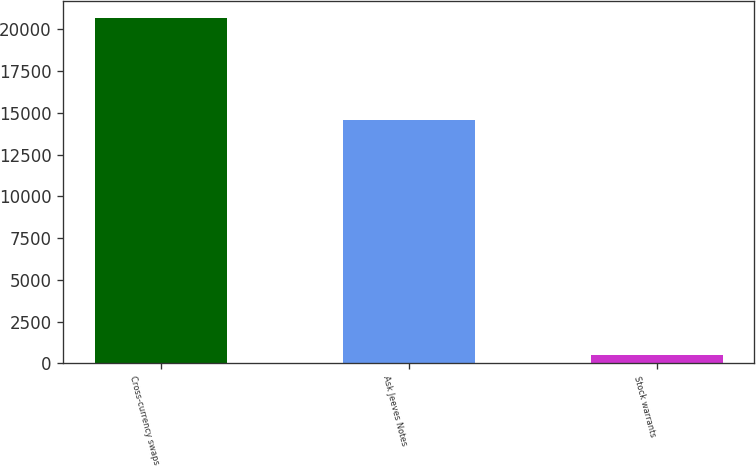Convert chart to OTSL. <chart><loc_0><loc_0><loc_500><loc_500><bar_chart><fcel>Cross-currency swaps<fcel>Ask Jeeves Notes<fcel>Stock warrants<nl><fcel>20682<fcel>14600<fcel>500<nl></chart> 